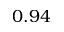Convert formula to latex. <formula><loc_0><loc_0><loc_500><loc_500>0 . 9 4</formula> 